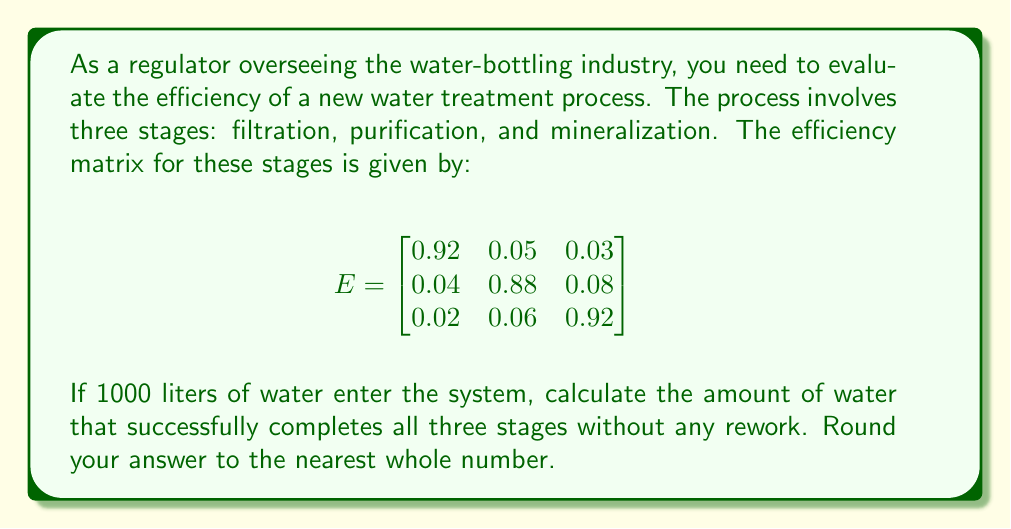Give your solution to this math problem. To solve this problem, we need to understand that the efficiency matrix E represents the probabilities of water moving through each stage or being sent back for rework.

1) The diagonal elements (0.92, 0.88, 0.92) represent the probability of water successfully passing through each stage.

2) To find the probability of water successfully completing all three stages without rework, we multiply these diagonal elements:

   $P(\text{success}) = 0.92 \times 0.88 \times 0.92$

3) Let's calculate this:
   
   $P(\text{success}) = 0.92 \times 0.88 \times 0.92 = 0.745984$

4) Now, to find the amount of water that successfully completes all stages from the initial 1000 liters:

   $\text{Successful water} = 1000 \times 0.745984 = 745.984$ liters

5) Rounding to the nearest whole number:

   $745.984 \approx 746$ liters

This method utilizes the properties of the efficiency matrix, where the diagonal elements represent the success rates for each stage, and their product gives the overall success rate for the entire process.
Answer: 746 liters 